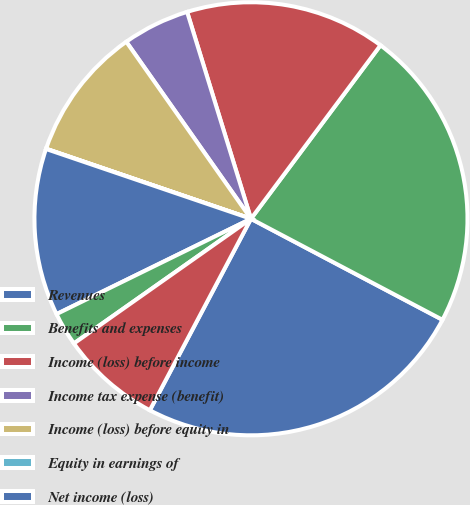Convert chart. <chart><loc_0><loc_0><loc_500><loc_500><pie_chart><fcel>Revenues<fcel>Benefits and expenses<fcel>Income (loss) before income<fcel>Income tax expense (benefit)<fcel>Income (loss) before equity in<fcel>Equity in earnings of<fcel>Net income (loss)<fcel>Less Income attributable to<fcel>Net income (loss) attributable<nl><fcel>25.01%<fcel>22.52%<fcel>14.97%<fcel>5.0%<fcel>9.99%<fcel>0.02%<fcel>12.48%<fcel>2.51%<fcel>7.5%<nl></chart> 